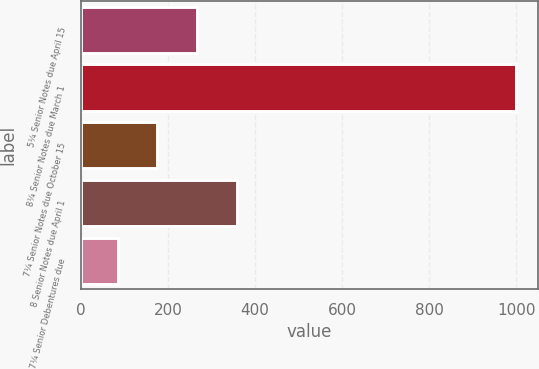Convert chart. <chart><loc_0><loc_0><loc_500><loc_500><bar_chart><fcel>5¼ Senior Notes due April 15<fcel>8¼ Senior Notes due March 1<fcel>7¼ Senior Notes due October 15<fcel>8 Senior Notes due April 1<fcel>7¼ Senior Debentures due<nl><fcel>267.2<fcel>1000<fcel>175.6<fcel>358.8<fcel>84<nl></chart> 